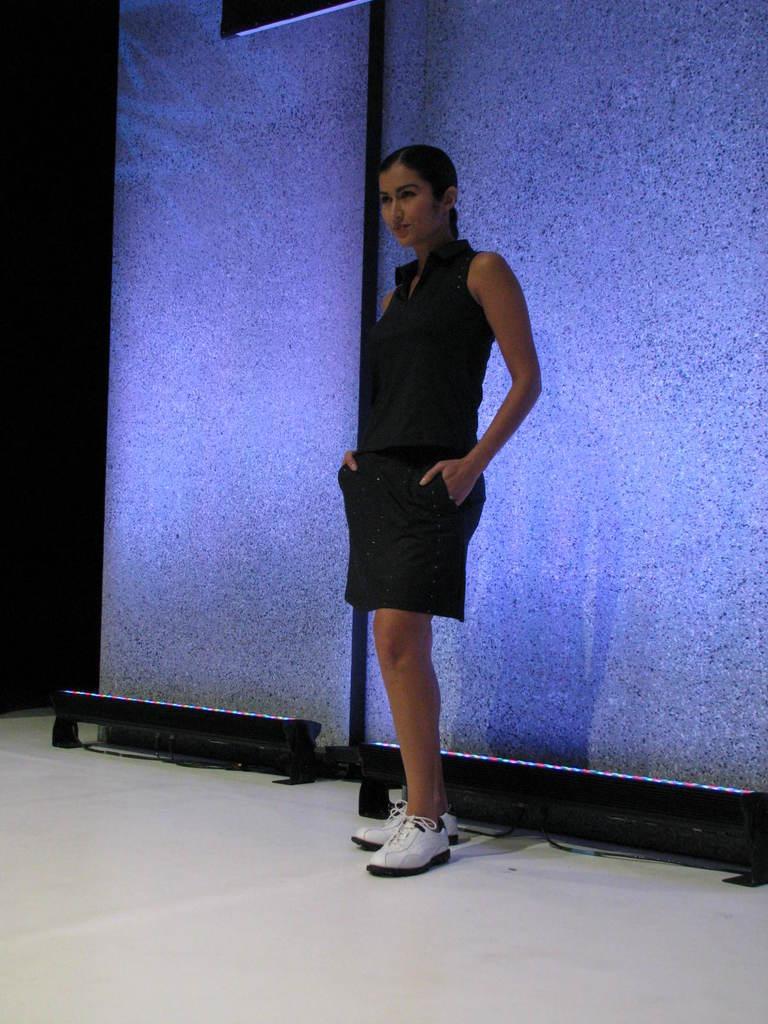How would you summarize this image in a sentence or two? The woman in the middle of the picture who is wearing black dress is stunning. She is wearing the white shoes. Behind her, we see a wall and an iron pole. On the left side, it is black in color. At the bottom of the picture, we see a white floor. 